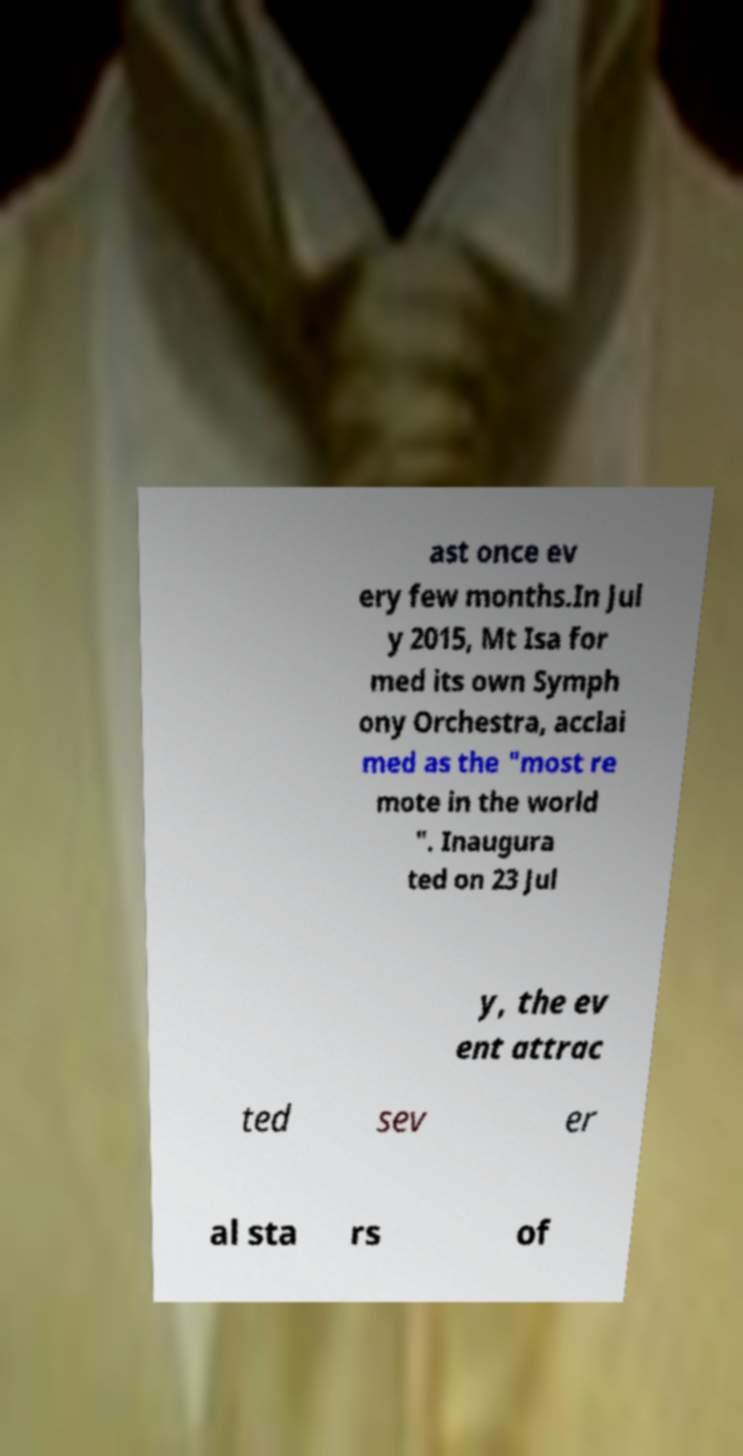I need the written content from this picture converted into text. Can you do that? ast once ev ery few months.In Jul y 2015, Mt Isa for med its own Symph ony Orchestra, acclai med as the "most re mote in the world ". Inaugura ted on 23 Jul y, the ev ent attrac ted sev er al sta rs of 